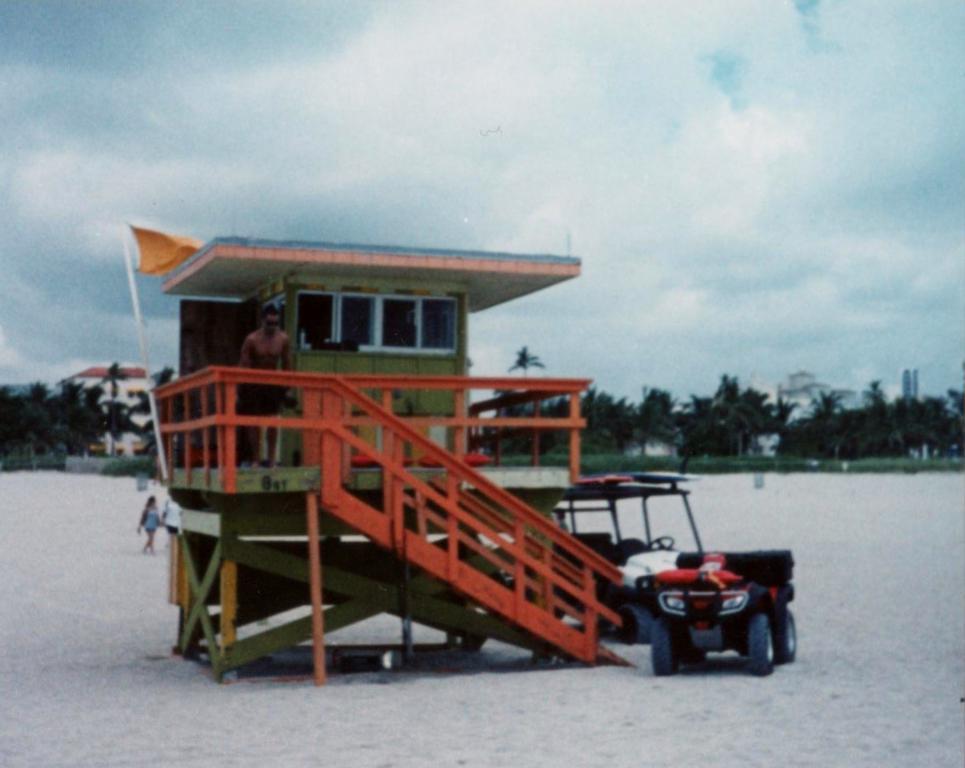How would you summarize this image in a sentence or two? In the center of the image we can see a person standing on the ground. In the foreground of the image we can see, railing, stair case, two vehicles parked on the ground. In the background, we can see some persons, group of trees, building and the sky 